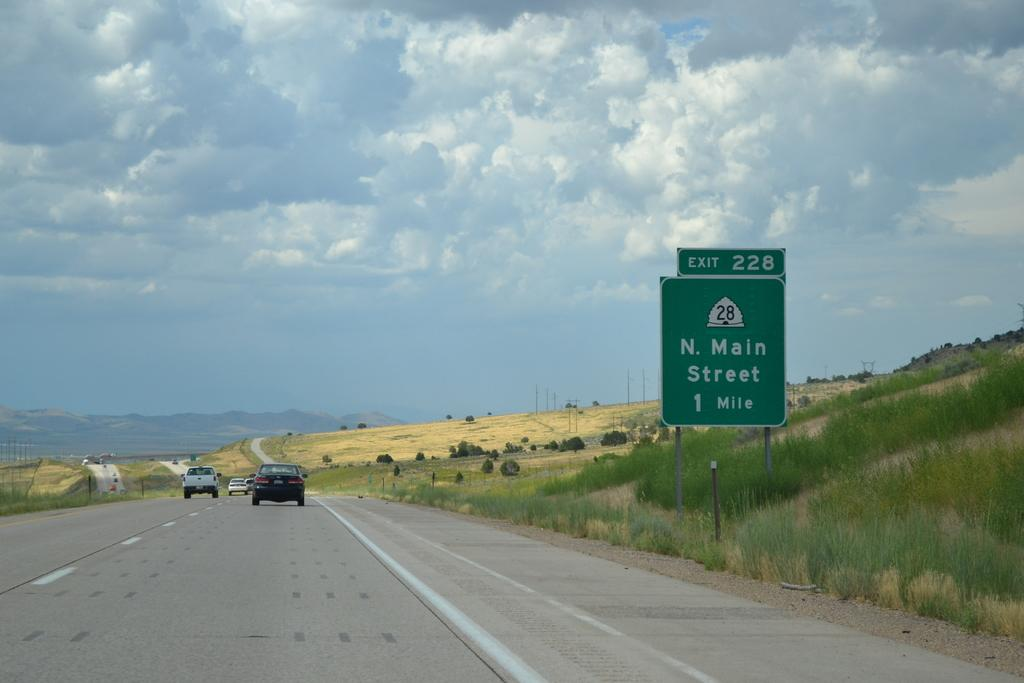<image>
Write a terse but informative summary of the picture. A road sign that shows N. Main Street is 1 mile away. 